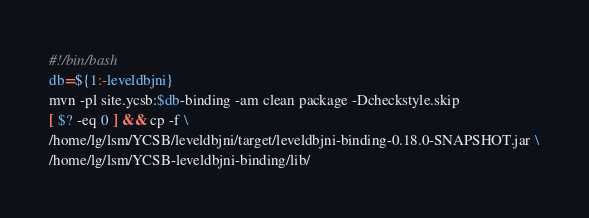Convert code to text. <code><loc_0><loc_0><loc_500><loc_500><_Bash_>#!/bin/bash
db=${1:-leveldbjni}
mvn -pl site.ycsb:$db-binding -am clean package -Dcheckstyle.skip
[ $? -eq 0 ] && cp -f \
/home/lg/lsm/YCSB/leveldbjni/target/leveldbjni-binding-0.18.0-SNAPSHOT.jar \
/home/lg/lsm/YCSB-leveldbjni-binding/lib/
</code> 